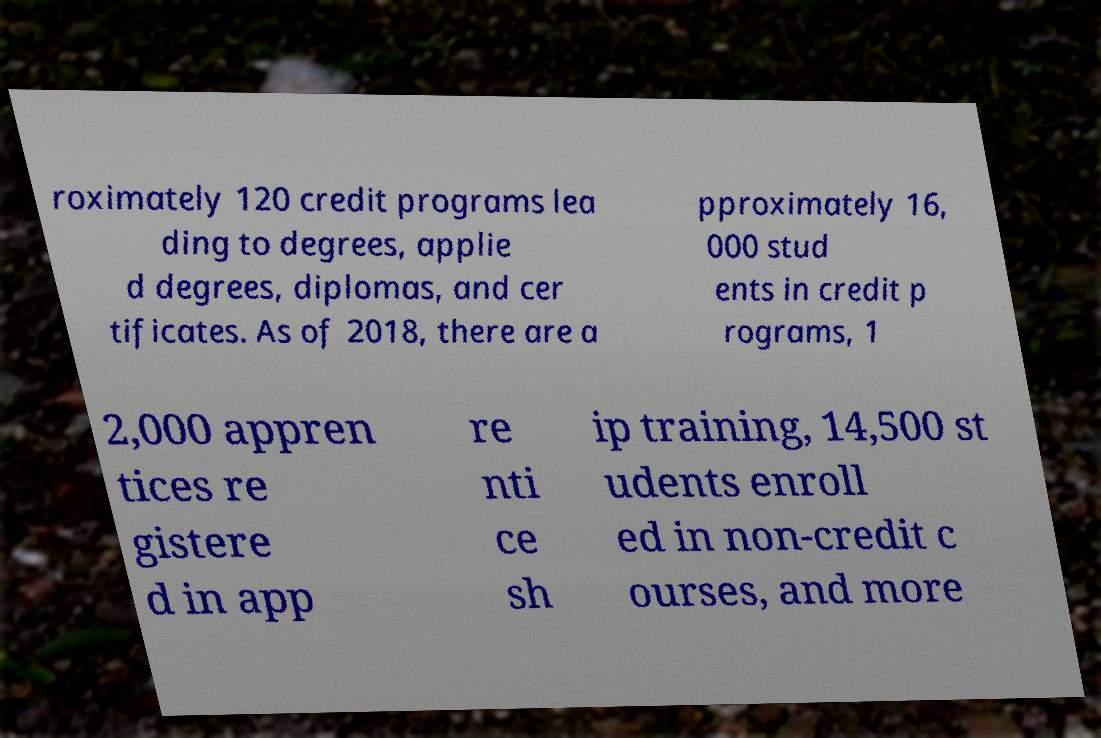Could you extract and type out the text from this image? roximately 120 credit programs lea ding to degrees, applie d degrees, diplomas, and cer tificates. As of 2018, there are a pproximately 16, 000 stud ents in credit p rograms, 1 2,000 appren tices re gistere d in app re nti ce sh ip training, 14,500 st udents enroll ed in non-credit c ourses, and more 